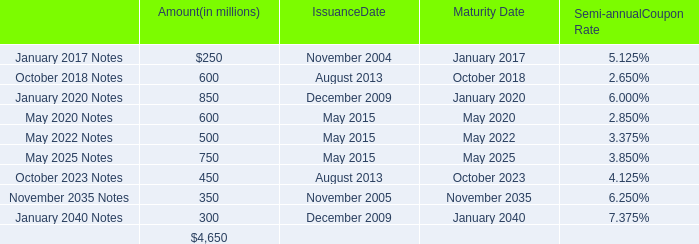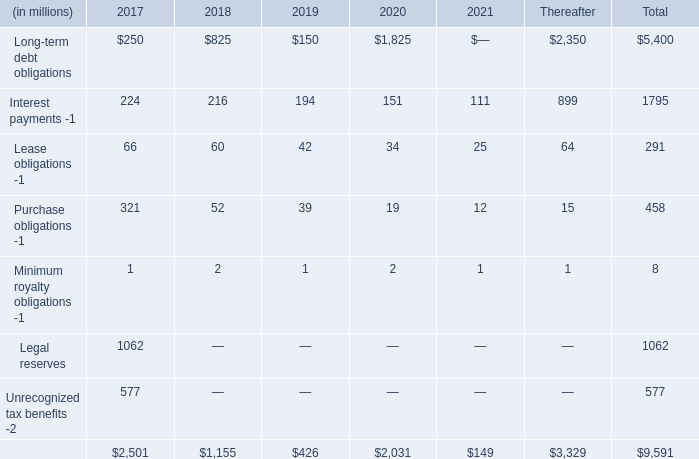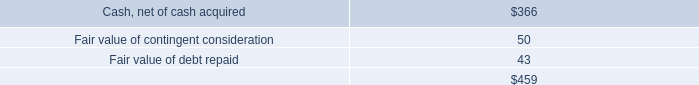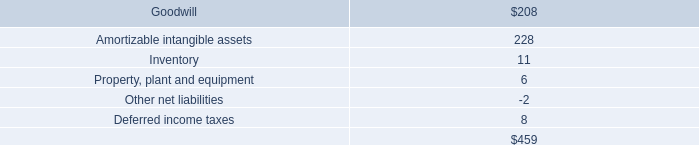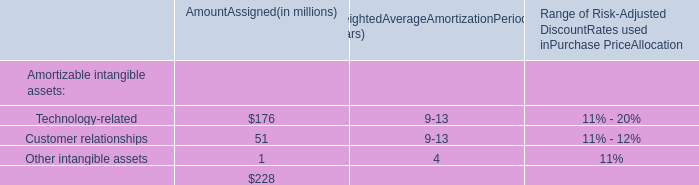In the year/section with the most Long-term debt obligations, what is the growth rate of Interest payments -1? 
Computations: ((216 - 194) / 194)
Answer: 0.1134. 